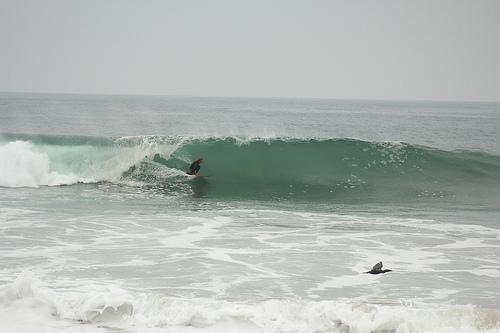How many people are pictured?
Give a very brief answer. 1. 